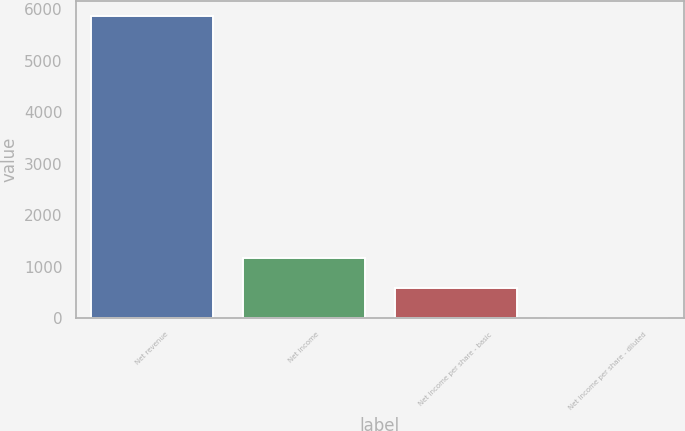Convert chart. <chart><loc_0><loc_0><loc_500><loc_500><bar_chart><fcel>Net revenue<fcel>Net income<fcel>Net income per share - basic<fcel>Net income per share - diluted<nl><fcel>5871<fcel>1175.68<fcel>588.76<fcel>1.84<nl></chart> 